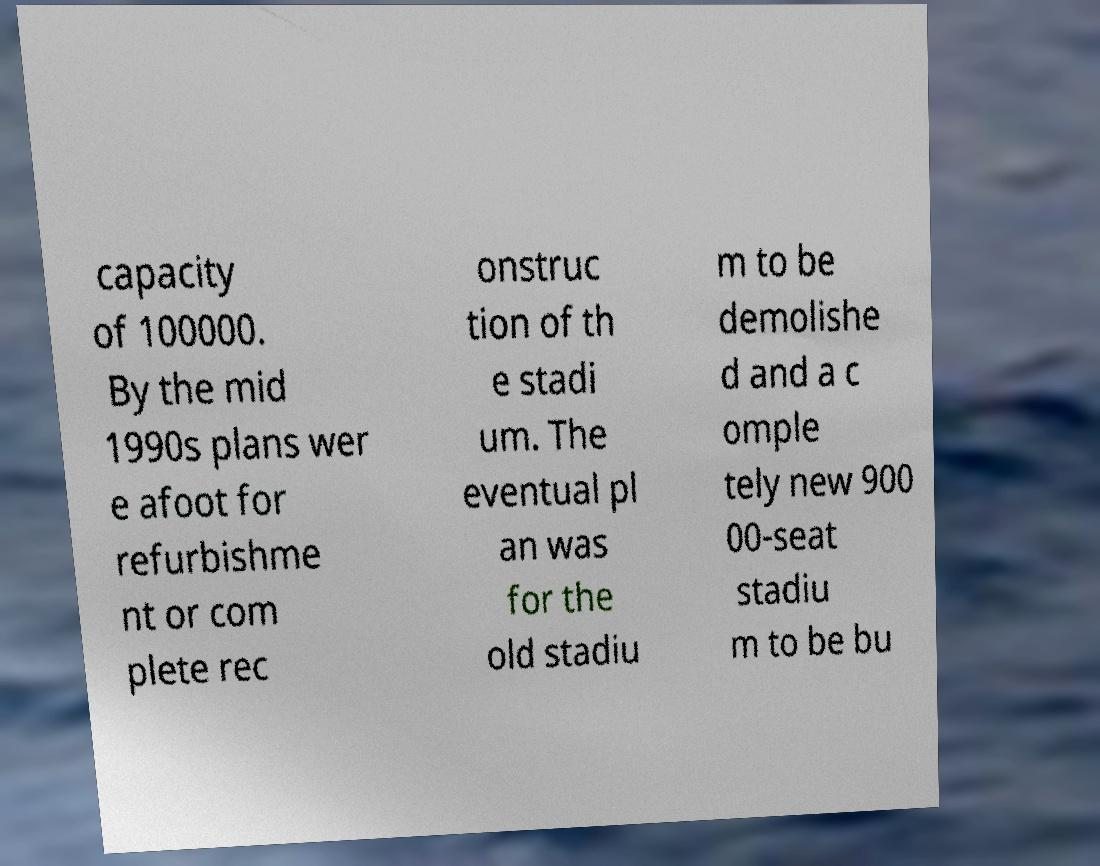Please identify and transcribe the text found in this image. capacity of 100000. By the mid 1990s plans wer e afoot for refurbishme nt or com plete rec onstruc tion of th e stadi um. The eventual pl an was for the old stadiu m to be demolishe d and a c omple tely new 900 00-seat stadiu m to be bu 